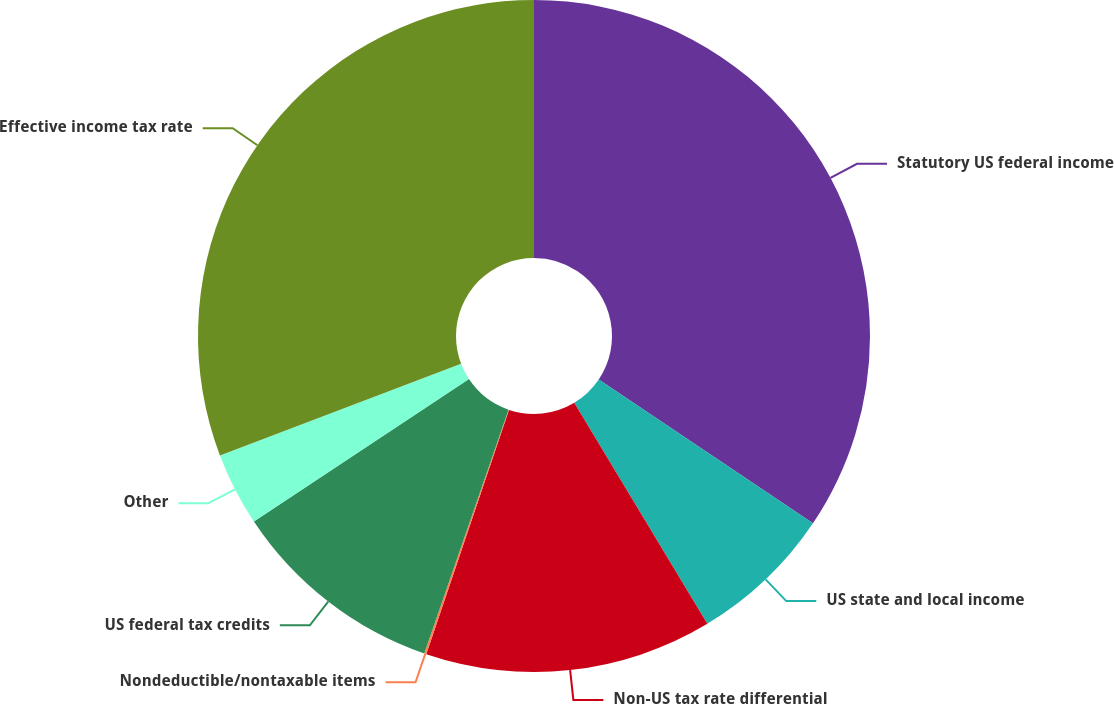<chart> <loc_0><loc_0><loc_500><loc_500><pie_chart><fcel>Statutory US federal income<fcel>US state and local income<fcel>Non-US tax rate differential<fcel>Nondeductible/nontaxable items<fcel>US federal tax credits<fcel>Other<fcel>Effective income tax rate<nl><fcel>34.41%<fcel>6.96%<fcel>13.82%<fcel>0.1%<fcel>10.39%<fcel>3.53%<fcel>30.78%<nl></chart> 